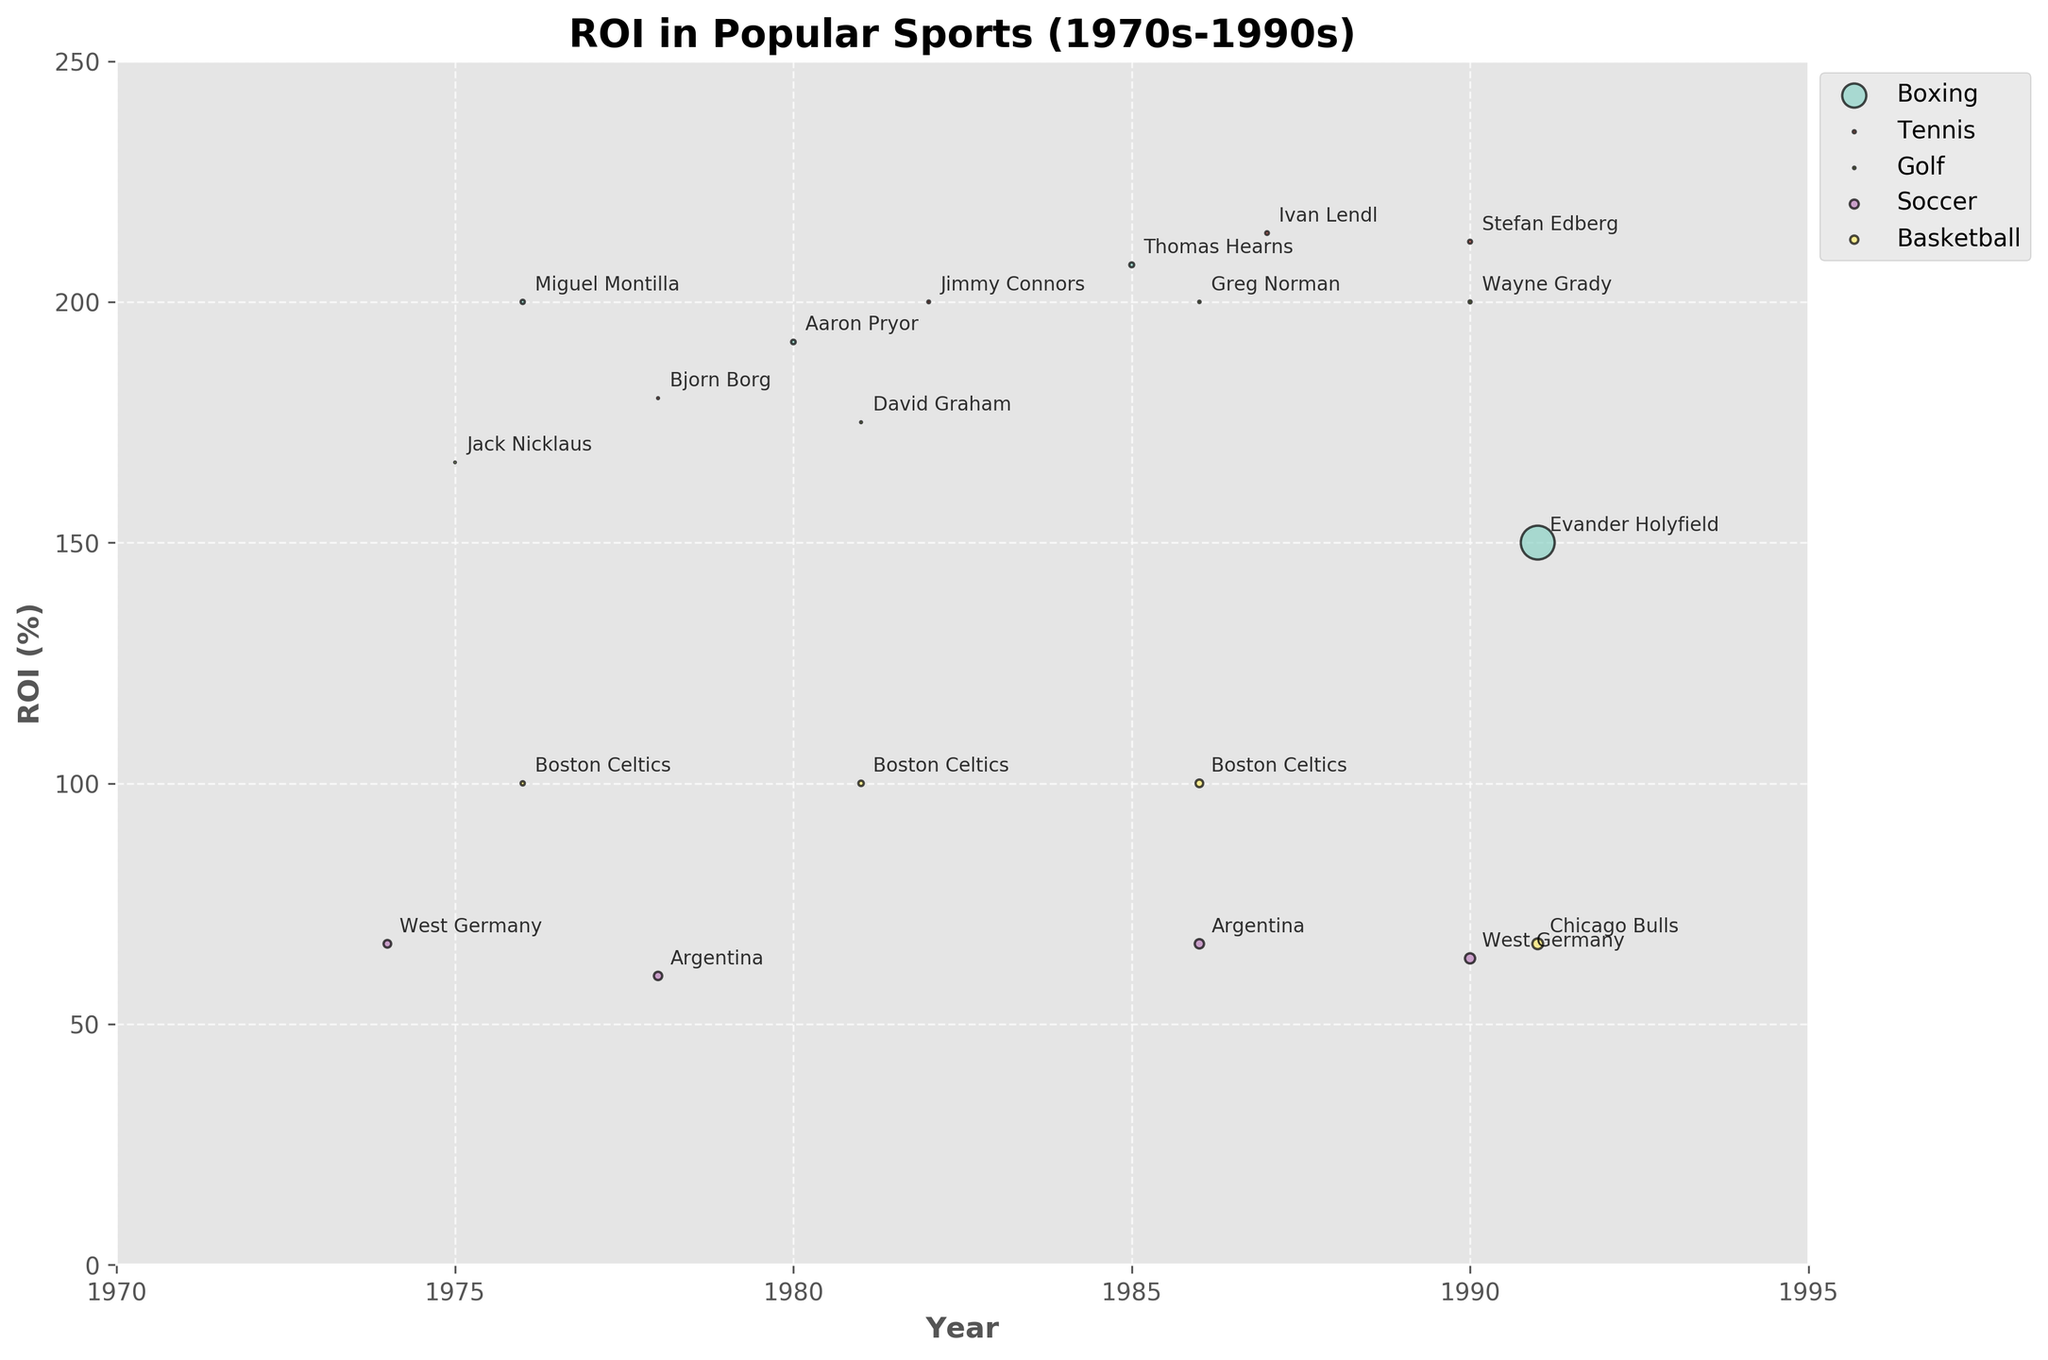What's the title of the chart? The title of the chart is usually located at the top center of the figure. Here, it is clearly displayed above the plot.
Answer: ROI in Popular Sports (1970s-1990s) How many sports are represented in the chart? Each unique sport category is represented by a different color in the scatter plot. By counting the different color groups and confirming against the legend, we can determine the number of sports.
Answer: 4 What sport had the highest ROI in the 1990s? To answer this, focus on the data points from the 1990s and compare their corresponding ROI values. Tennis (Stefan Edberg) has the highest ROI at 212.5%.
Answer: Tennis Which sport has the most consistent ROI value across all years? By observing the chart, we can see that Basketball has consistently similar ROI values across different years, all around the 100% mark.
Answer: Basketball Who was the champion with the highest prize money in the chart, and what was the amount? To find this, look for the largest bubble in the chart and then read the attached label for the champion and prize money. The largest bubble corresponds to Boxing in 1991, with Evander Holyfield.
Answer: Evander Holyfield, 20,000,000 USD In which year did Golf have its highest ROI and who was the champion? To answer this, look at the data points corresponding to Golf and compare their ROI values. Greg Norman in 1986 had the highest ROI for Golf at 200%.
Answer: 1986, Greg Norman Compare the ROI of Tennis champions between 1982 and 1987. Who had the higher ROI and by how much? By comparing Ivan Lendl’s ROI in 1987 (214.29%) with Jimmy Connors’ in 1982 (200%), the difference can be calculated.
Answer: Ivan Lendl had a higher ROI by 14.29% How does the ROI for the FIFA World Cup in 1990 compare to 1974? By examining the data points for FIFA World Cup and comparing ROI values from 1990 (63.64%) to 1974 (66.67%), we see the 1974 value is higher.
Answer: 1974 (66.67%) is higher than 1990 (63.64%) What is the range of years represented in the chart? The range is determined by the earliest and latest years on the x-axis. The chart ranges from 1970 to 1995.
Answer: 1974-1991 Which champion had the highest ROI in the Boxing category? By examining the Boxing data points, Thomas Hearns in 1985 stands out with the highest ROI at 207.69%.
Answer: Thomas Hearns 